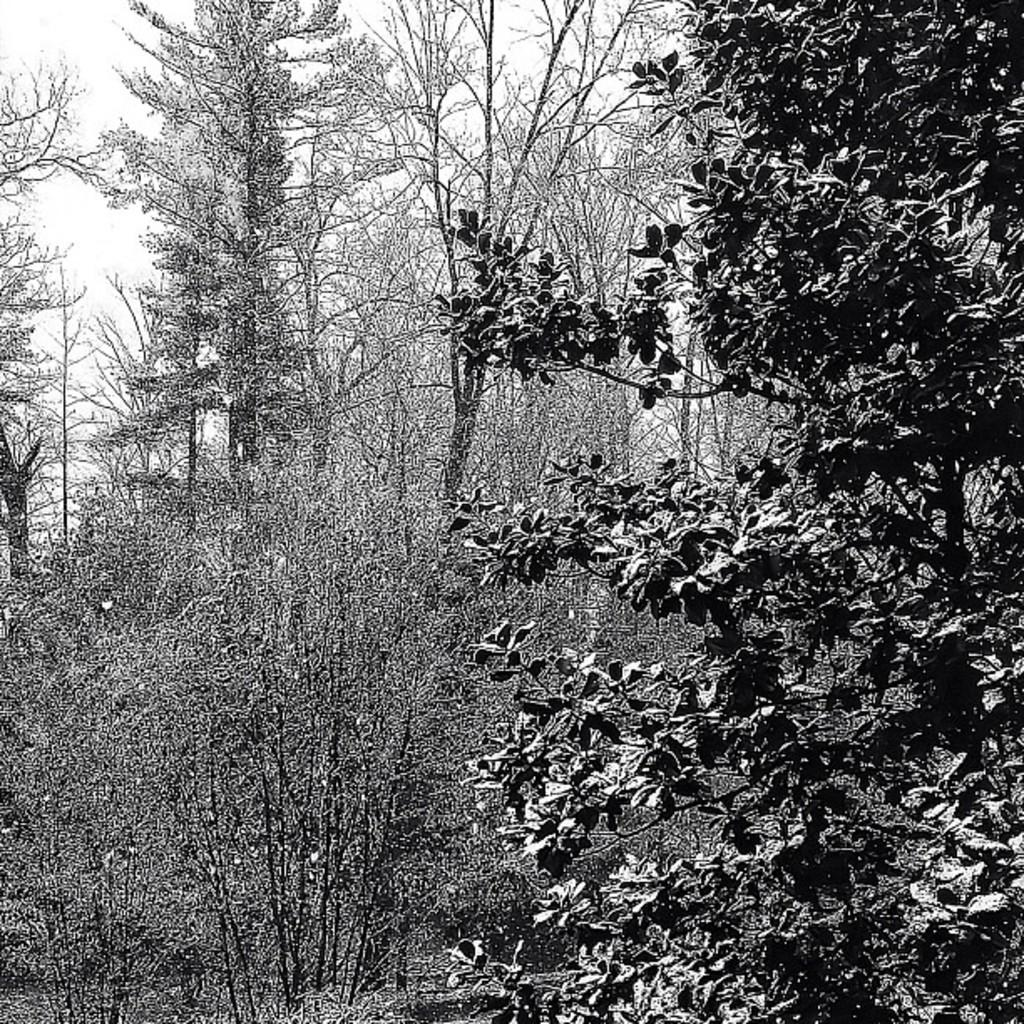What is the color scheme of the image? The image is black and white. What can be seen in the image besides the sky? There is a group of trees in the image. What is the condition of the trees in the image? The trees are covered with snow. What song is being sung by the rabbits in the image? There are no rabbits present in the image, and therefore no song can be heard. 